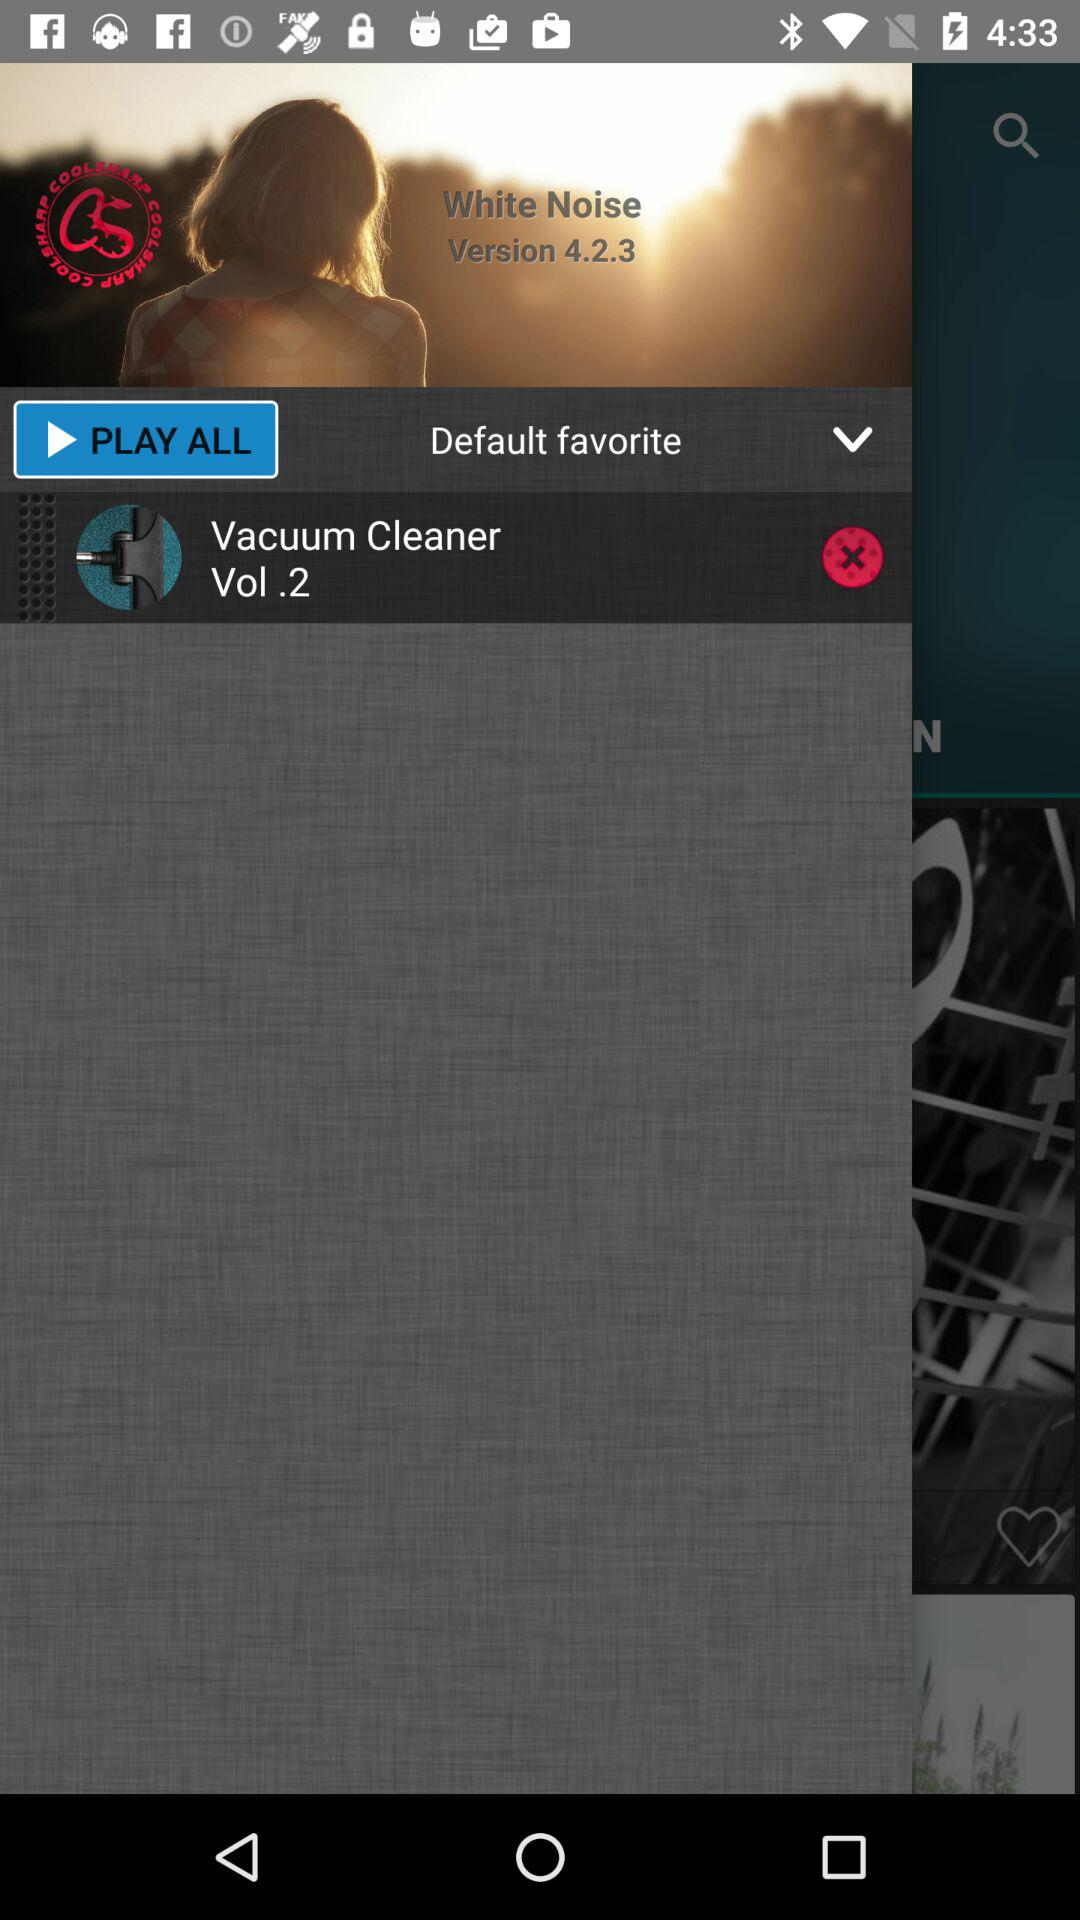What is the version? The version is 4.2.3. 